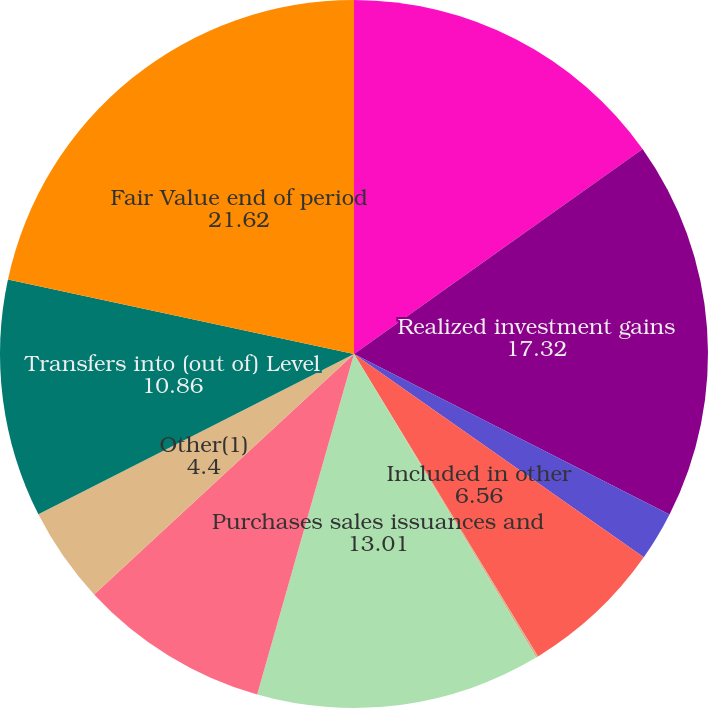Convert chart to OTSL. <chart><loc_0><loc_0><loc_500><loc_500><pie_chart><fcel>Fair Value beginning of period<fcel>Realized investment gains<fcel>Asset management fees and<fcel>Included in other<fcel>Net investment income<fcel>Purchases sales issuances and<fcel>Foreign currency translation<fcel>Other(1)<fcel>Transfers into (out of) Level<fcel>Fair Value end of period<nl><fcel>15.17%<fcel>17.32%<fcel>2.25%<fcel>6.56%<fcel>0.1%<fcel>13.01%<fcel>8.71%<fcel>4.4%<fcel>10.86%<fcel>21.62%<nl></chart> 